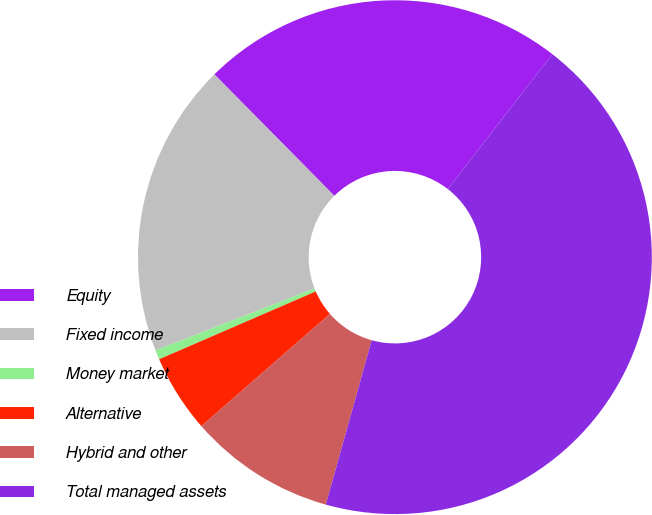Convert chart to OTSL. <chart><loc_0><loc_0><loc_500><loc_500><pie_chart><fcel>Equity<fcel>Fixed income<fcel>Money market<fcel>Alternative<fcel>Hybrid and other<fcel>Total managed assets<nl><fcel>22.9%<fcel>18.51%<fcel>0.59%<fcel>4.92%<fcel>9.24%<fcel>43.83%<nl></chart> 